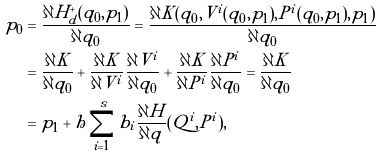Convert formula to latex. <formula><loc_0><loc_0><loc_500><loc_500>p _ { 0 } & = \frac { \partial H _ { d } ^ { + } ( q _ { 0 } , p _ { 1 } ) } { \partial q _ { 0 } } = \frac { \partial K ( q _ { 0 } , V ^ { i } ( q _ { 0 } , p _ { 1 } ) , P ^ { i } ( q _ { 0 } , p _ { 1 } ) , p _ { 1 } ) } { \partial q _ { 0 } } \\ & = \frac { \partial K } { \partial q _ { 0 } } + \frac { \partial K } { \partial V ^ { i } } \frac { \partial V ^ { i } } { \partial q _ { 0 } } + \frac { \partial K } { \partial P ^ { i } } \frac { \partial P ^ { i } } { \partial q _ { 0 } } = \frac { \partial K } { \partial q _ { 0 } } \\ & = p _ { 1 } + h \sum _ { i = 1 } ^ { s } b _ { i } \frac { \partial H } { \partial q } ( Q ^ { i } , P ^ { i } ) ,</formula> 